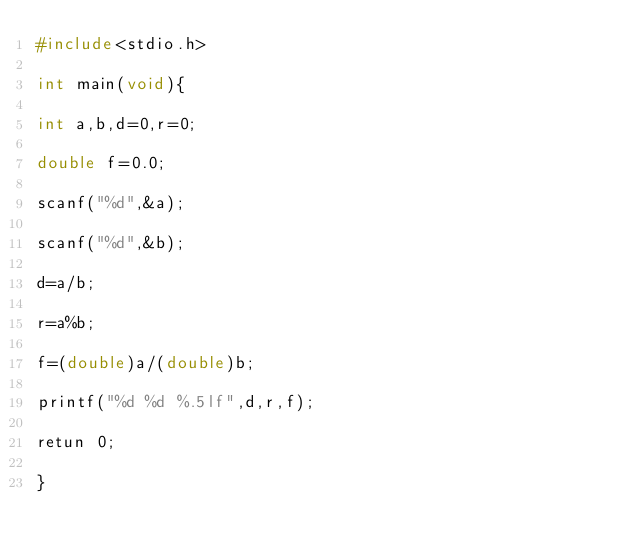Convert code to text. <code><loc_0><loc_0><loc_500><loc_500><_C_>#include<stdio.h>

int main(void){

int a,b,d=0,r=0;

double f=0.0;

scanf("%d",&a);

scanf("%d",&b);

d=a/b;

r=a%b;

f=(double)a/(double)b;

printf("%d %d %.5lf",d,r,f);

retun 0;

}</code> 